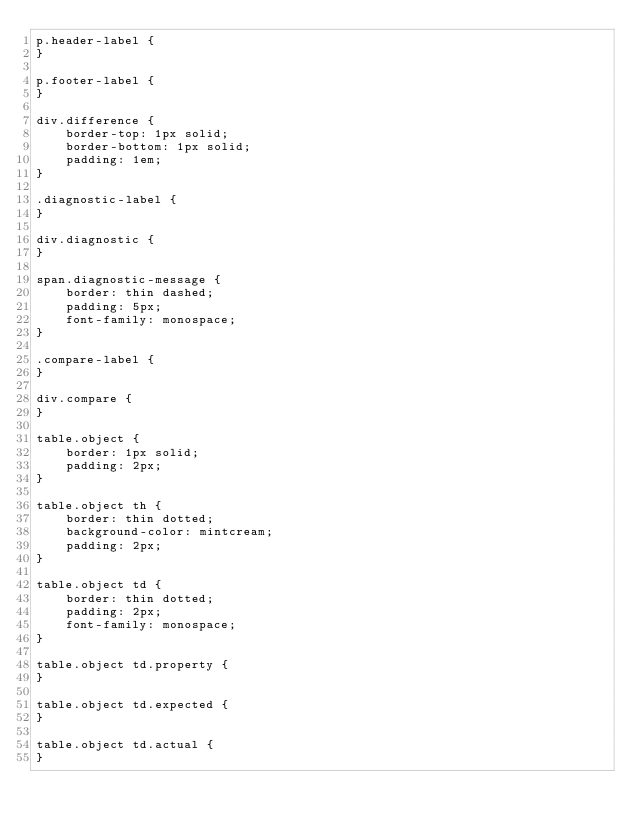Convert code to text. <code><loc_0><loc_0><loc_500><loc_500><_CSS_>p.header-label {
}

p.footer-label {
}

div.difference {
    border-top: 1px solid;
    border-bottom: 1px solid;
    padding: 1em;
}

.diagnostic-label {
}

div.diagnostic {
}

span.diagnostic-message {
    border: thin dashed;
    padding: 5px;
    font-family: monospace;
}

.compare-label {
}

div.compare {
}

table.object {
    border: 1px solid;
    padding: 2px;
}

table.object th {
    border: thin dotted;
    background-color: mintcream;
    padding: 2px;
}

table.object td {
    border: thin dotted;
    padding: 2px;
    font-family: monospace;
}

table.object td.property {
}

table.object td.expected {
}

table.object td.actual {
}
</code> 